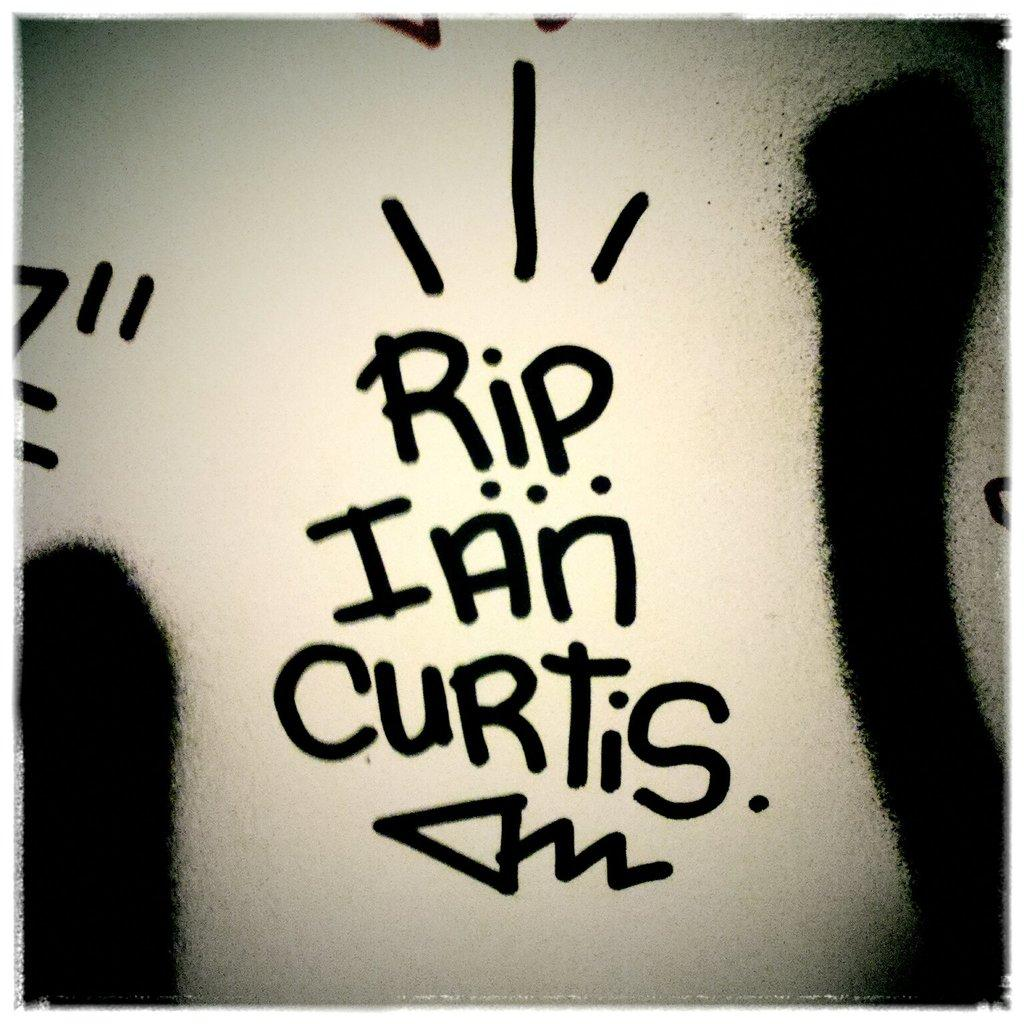<image>
Render a clear and concise summary of the photo. Someone has written R.I.P. Ian Curtis with a squiggly arrow underneath the words. 